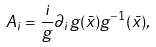<formula> <loc_0><loc_0><loc_500><loc_500>A _ { i } = \frac { i } { g } \partial _ { i } g ( \bar { x } ) g ^ { - 1 } ( \bar { x } ) ,</formula> 